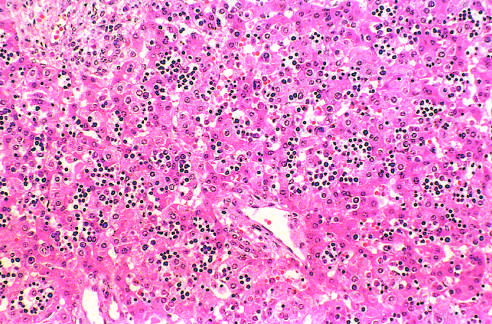re numerous islands of extramedullary hematopoiesis scattered among mature hepatocytes in this histologic preparation from an infant with nonimmune hydrops fetalis?
Answer the question using a single word or phrase. Yes 